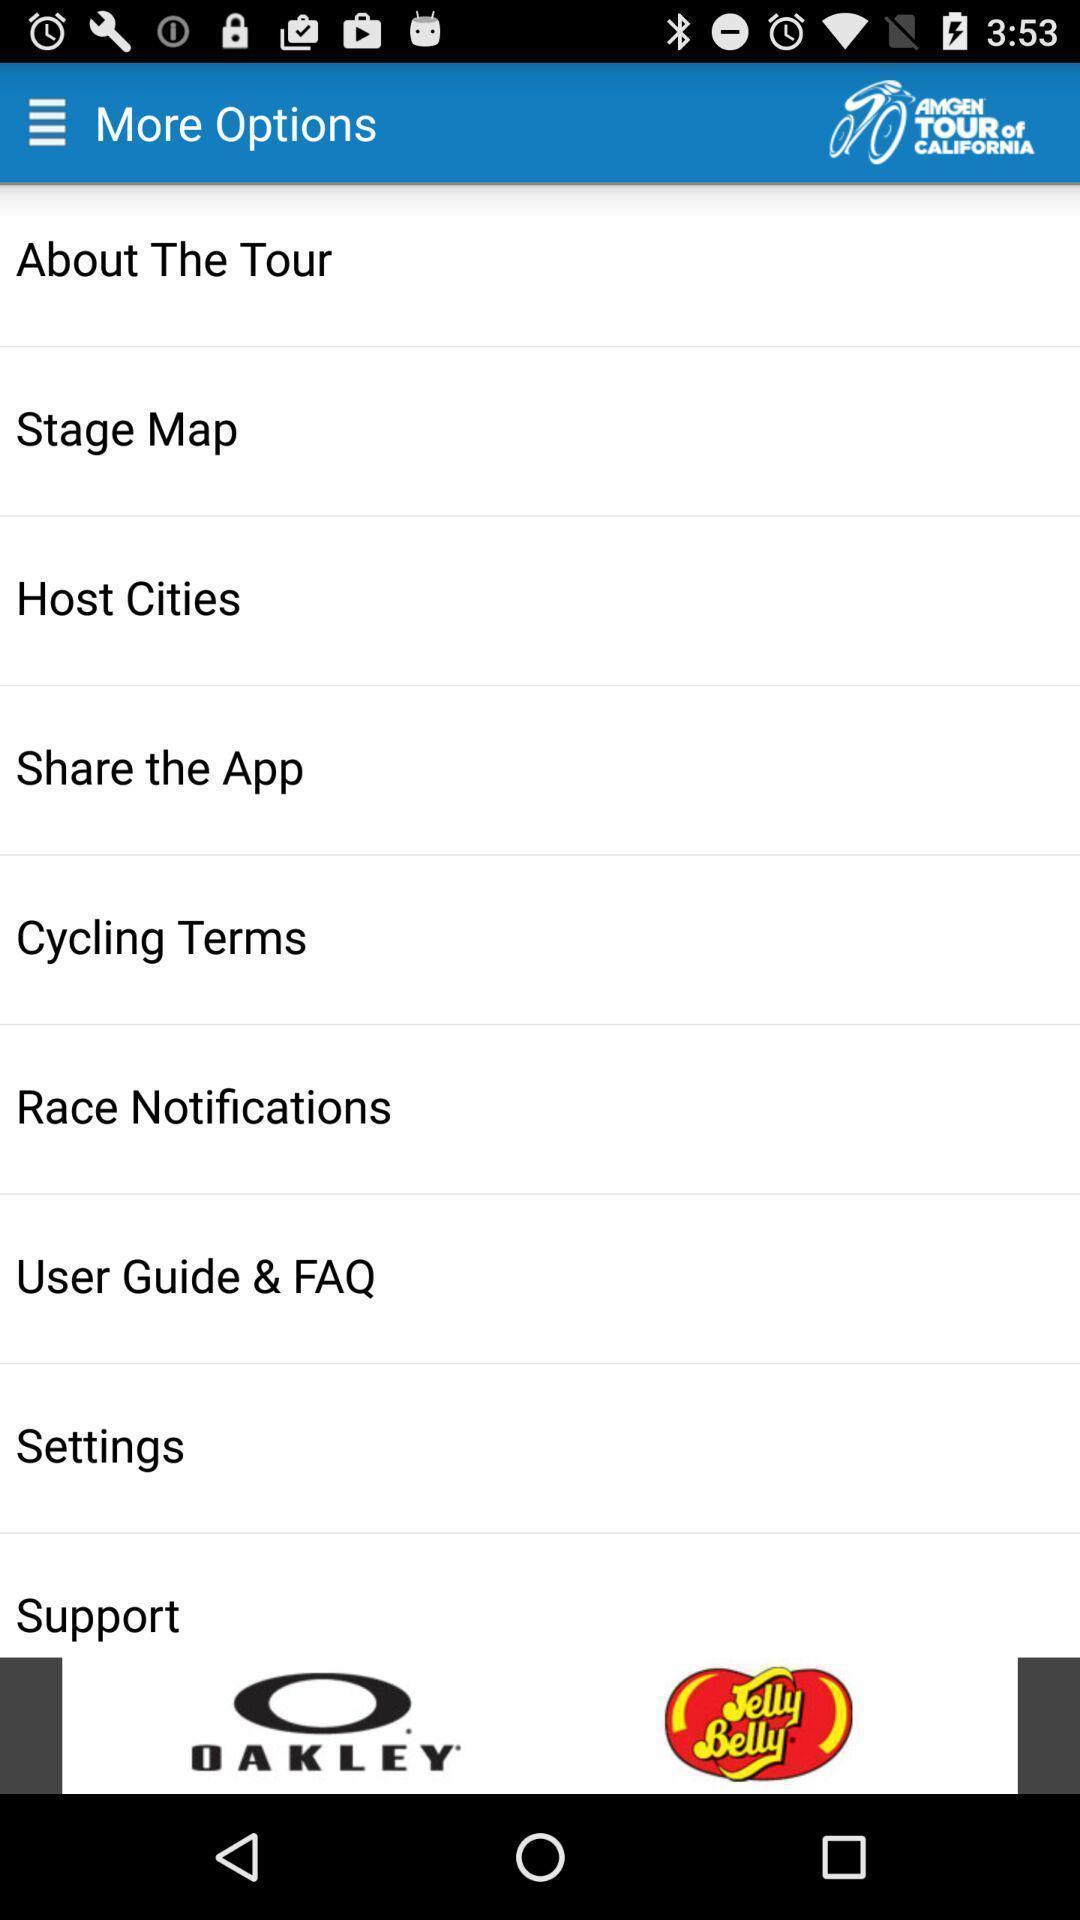Summarize the main components in this picture. Screen shows different options in tour tracker app. 